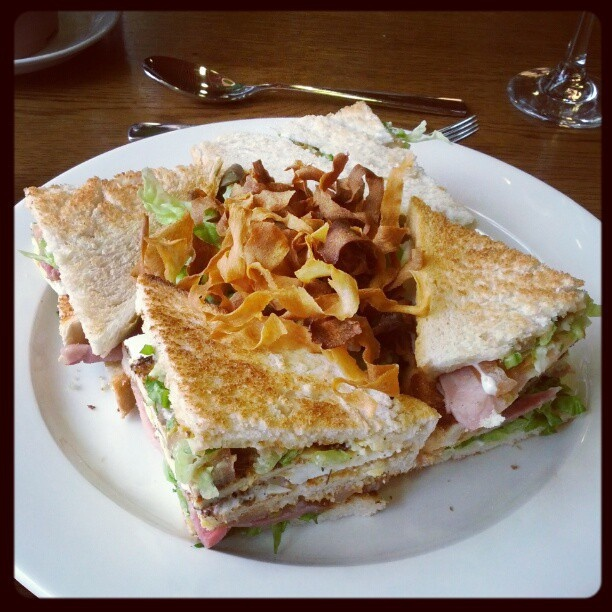Describe the objects in this image and their specific colors. I can see dining table in lightgray, maroon, black, darkgray, and olive tones, sandwich in black, olive, tan, and darkgray tones, sandwich in black, darkgray, tan, and olive tones, sandwich in black, tan, and lightgray tones, and sandwich in black, lightgray, darkgray, and tan tones in this image. 